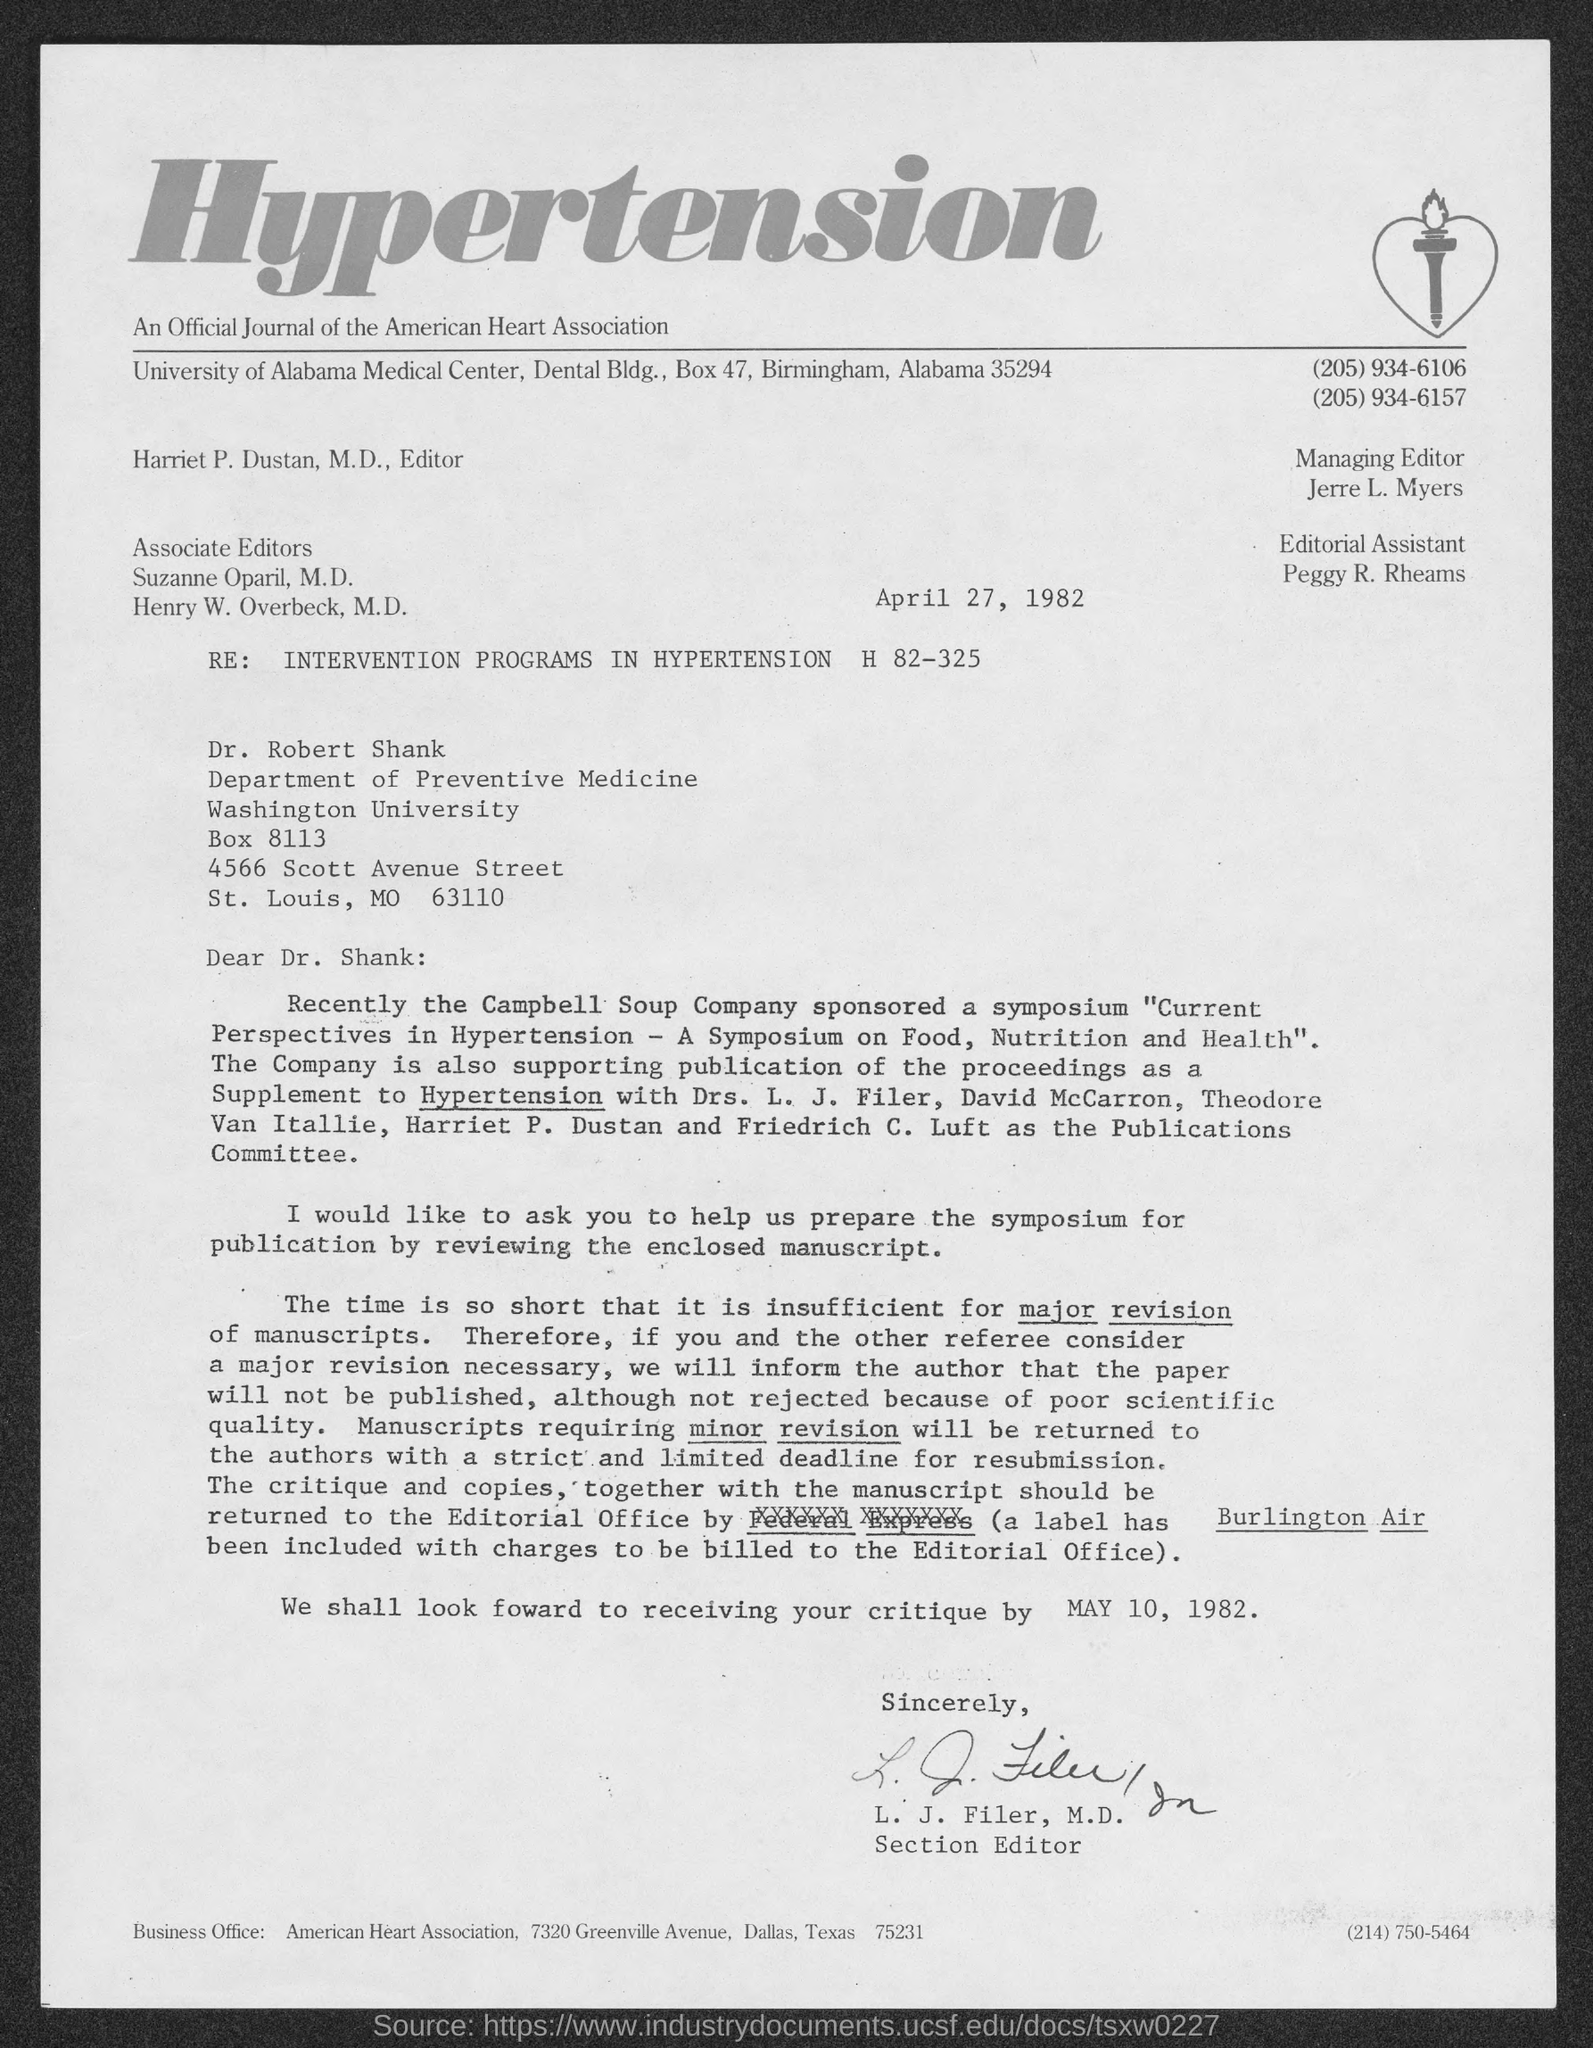Draw attention to some important aspects in this diagram. Harriet P. Dustan, M.D. holds the position of editor. The University of Alabama Medical Center is located in Birmingham. Peggy R. Rheams holds the position of editorial assistant. L.J. Filer, M.D. holds the position of section editor. The American Heart Association is located in Dallas, a city in the United States. 